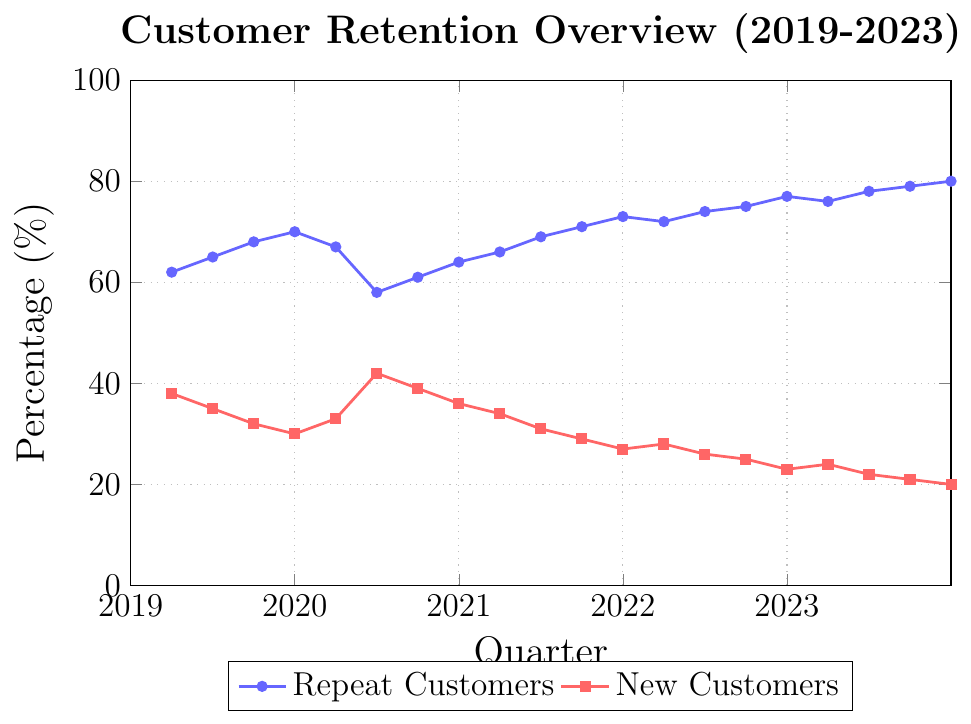What is the percentage of repeat customers for Q2 2020? Locate the data point for Q2 2020 on the 'Repeat Customers' line (blue). The value is at 58% according to the y-axis.
Answer: 58% Did the percentage of new customers increase or decrease from Q3 to Q4 in 2021? Compare the data points for Q3 and Q4 in 2021 on the 'New Customers' line (red). Q3 is at 29% and Q4 is at 27%, showing a decrease.
Answer: Decrease What is the difference in percentage points between repeat customers and new customers in Q4 2019? Locate Q4 2019 on both lines. Repeat Customers is at 70%, New Customers is at 30%. The difference is 70% - 30% = 40%.
Answer: 40% Which quarter saw the highest percentage of repeat customers? Identify the highest point on the 'Repeat Customers' line (blue). It's Q4 2023 at 80%.
Answer: Q4 2023 What was the percentage change in repeat customers from Q2 2020 to Q3 2020? Locate Q2 2020 (58%) and Q3 2020 (61%) on the 'Repeat Customers' line. Calculate the percentage change: (61 - 58) / 58 * 100 = 5.17%.
Answer: 5.17% Between 2019 and 2023, in which quarter did new customers have their peak percentage? Identify the highest point on the 'New Customers' line (red). It's Q2 2020 at 42%.
Answer: Q2 2020 During which quarter did the percentage of repeat customers first exceed 75%? Look for the first data point on the 'Repeat Customers' line (blue) above 75%. It's Q3 2022 at 75%.
Answer: Q3 2022 Compare the trend of repeat customers from 2019 to 2023 with new customers over the same period. Observe the overall direction of both lines. The 'Repeat Customers' line generally increases, while the 'New Customers' line generally decreases.
Answer: Repeat increases, New decreases How many quarters in total recorded more than 70% repeat customers? Count the number of data points above 70% on the 'Repeat Customers' line. There are 5 quarters (Q4 2021 to Q4 2023).
Answer: 5 Calculate the average percentage of new customers over the last year (2023). Sum the new customers percentages for Q1 to Q4 of 2023: (24 + 22 + 21 + 20) and divide by 4. (24+22+21+20)/4 = 21.75%.
Answer: 21.75% 